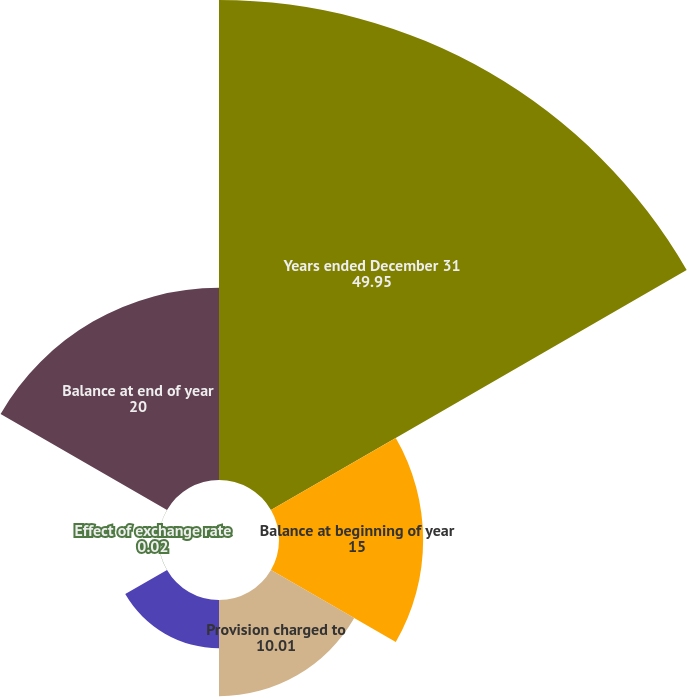Convert chart. <chart><loc_0><loc_0><loc_500><loc_500><pie_chart><fcel>Years ended December 31<fcel>Balance at beginning of year<fcel>Provision charged to<fcel>Accounts written off net of<fcel>Effect of exchange rate<fcel>Balance at end of year<nl><fcel>49.95%<fcel>15.0%<fcel>10.01%<fcel>5.02%<fcel>0.02%<fcel>20.0%<nl></chart> 